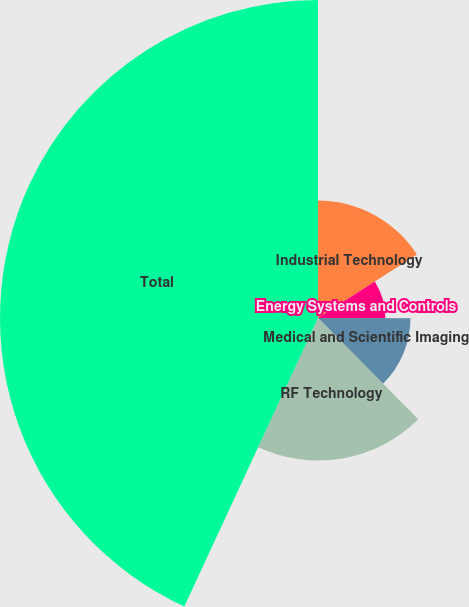Convert chart. <chart><loc_0><loc_0><loc_500><loc_500><pie_chart><fcel>Industrial Technology<fcel>Energy Systems and Controls<fcel>Medical and Scientific Imaging<fcel>RF Technology<fcel>Total<nl><fcel>15.92%<fcel>9.13%<fcel>12.53%<fcel>19.32%<fcel>43.09%<nl></chart> 